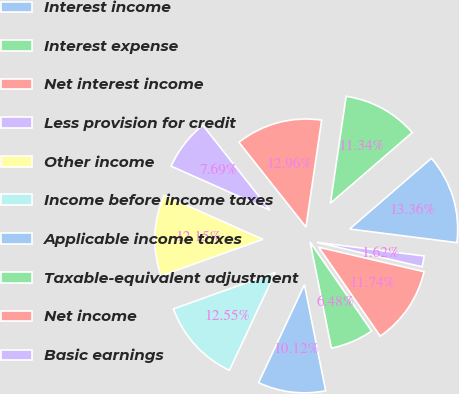Convert chart. <chart><loc_0><loc_0><loc_500><loc_500><pie_chart><fcel>Interest income<fcel>Interest expense<fcel>Net interest income<fcel>Less provision for credit<fcel>Other income<fcel>Income before income taxes<fcel>Applicable income taxes<fcel>Taxable-equivalent adjustment<fcel>Net income<fcel>Basic earnings<nl><fcel>13.36%<fcel>11.34%<fcel>12.96%<fcel>7.69%<fcel>12.15%<fcel>12.55%<fcel>10.12%<fcel>6.48%<fcel>11.74%<fcel>1.62%<nl></chart> 